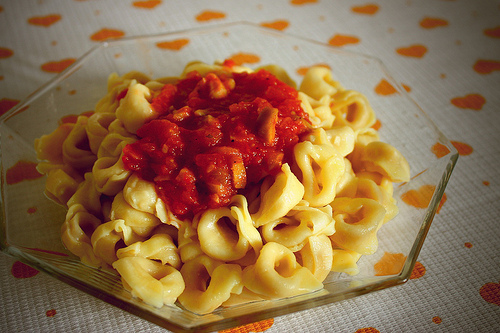<image>
Can you confirm if the sauce is on the pasta? Yes. Looking at the image, I can see the sauce is positioned on top of the pasta, with the pasta providing support. Where is the pasta in relation to the sauce? Is it under the sauce? Yes. The pasta is positioned underneath the sauce, with the sauce above it in the vertical space. 